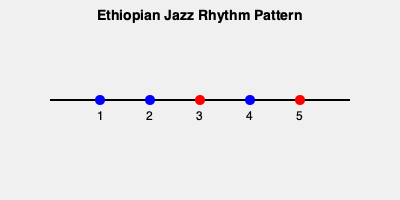Analyze the rhythmic pattern shown in the diagram, which represents a typical Ethiopian jazz rhythm. How does this pattern differ from more mainstream jazz rhythms, and what fraction of the beats are emphasized (represented by red dots)? To analyze this Ethiopian jazz rhythm pattern and compare it to mainstream jazz:

1. Observe the pattern:
   - There are 5 beats in total, represented by the dots.
   - Beats 3 and 5 are emphasized (red), while 1, 2, and 4 are not (blue).

2. Compare to mainstream jazz:
   - Mainstream jazz typically uses a 4/4 time signature with emphasis on beats 2 and 4.
   - This Ethiopian pattern uses a 5/4 time signature, which is less common.
   - The emphasis is on beats 3 and 5, creating a unique syncopated feel.

3. Calculate the fraction of emphasized beats:
   - Total beats: 5
   - Emphasized beats: 2
   - Fraction: $\frac{2}{5}$

4. Significance:
   - This rhythm creates a distinctive, off-kilter feel that sets Ethiopian jazz apart.
   - It incorporates traditional Ethiopian rhythms into the jazz context.
   - The unusual time signature and emphasis pattern contribute to the "underdog" status of this subgenre in the broader jazz world.
Answer: $\frac{2}{5}$ of beats emphasized; 5/4 time signature with emphasis on 3 and 5 